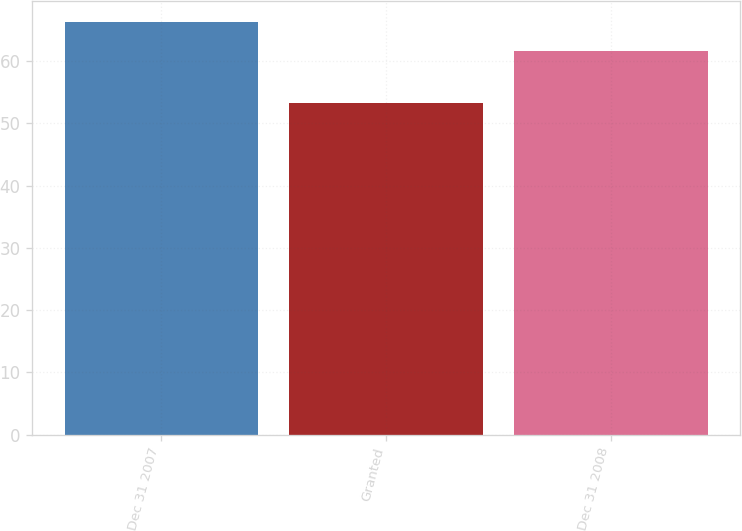<chart> <loc_0><loc_0><loc_500><loc_500><bar_chart><fcel>Dec 31 2007<fcel>Granted<fcel>Dec 31 2008<nl><fcel>66.28<fcel>53.27<fcel>61.63<nl></chart> 